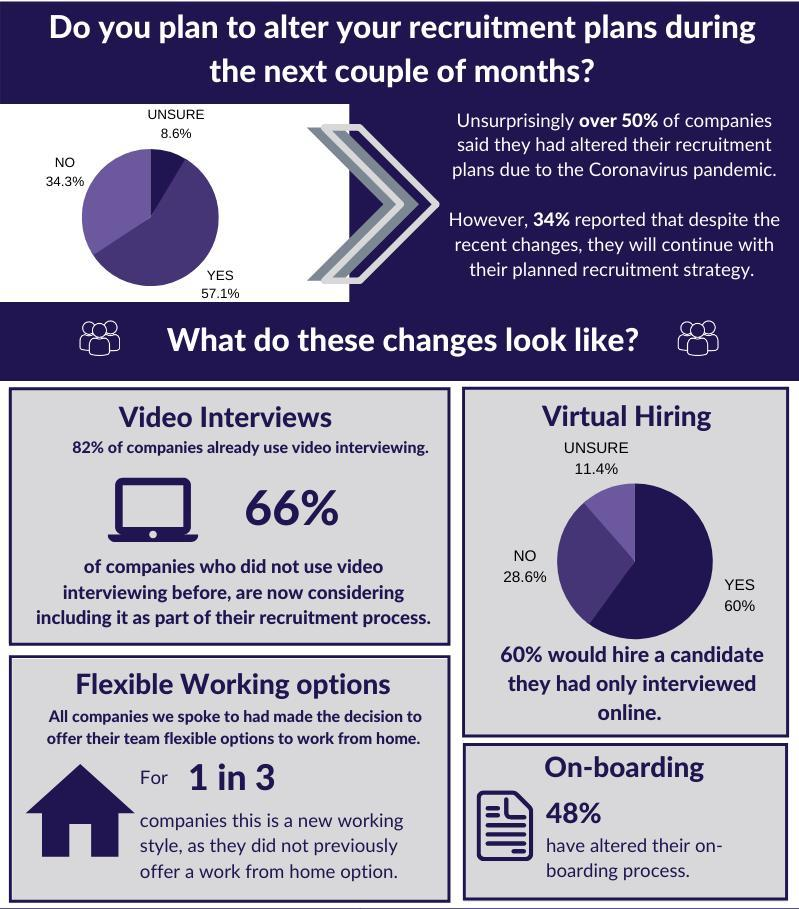What are the different opinions of businesses towards online interview job allocation?
Answer the question with a short phrase. Unsure, No, Yes What is the inverse percentage of businesses who have not decided yet to hire or not? 91.4 What percentage of companies are not confident about hiring a person without meeting them? 11.4% What percentage of companies are new to the online hiring procedure? 66% What percentage of businesses decided not to make any changes in their recruitment plan? 52 What percentage of businesses go on to hire employees in the present situation? 34.3% What percentage of companies encouraged work from home practice before pandemic out of 3? 2 What percentage of businesses won't take up aspirants through virtual hiring? 28.6% What percentage of companies were following online hiring before pandemic? 82% 